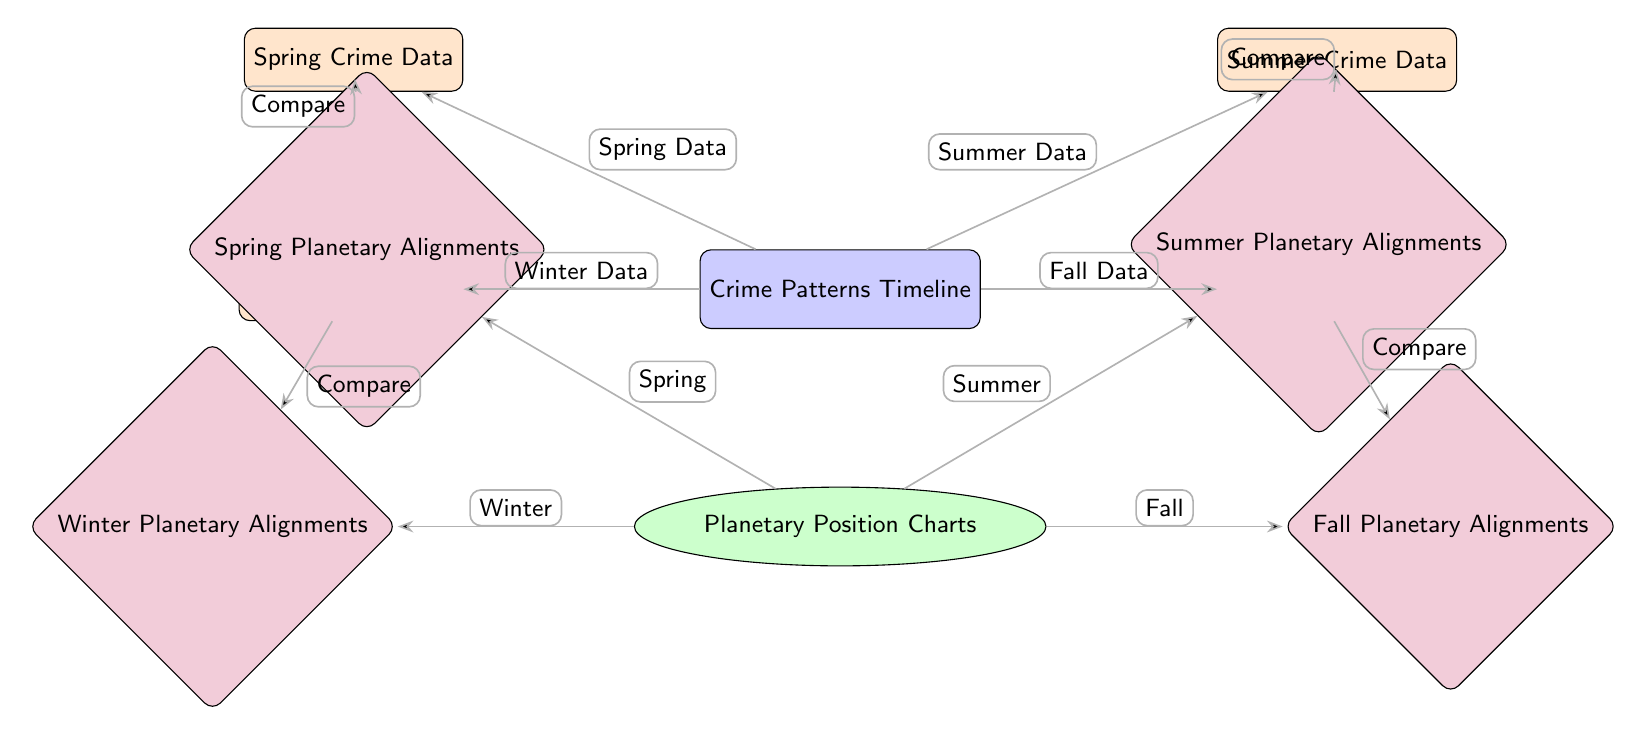What is the title of the diagram? The title is displayed at the top node of the diagram, which explicitly states "Crime Patterns Timeline."
Answer: Crime Patterns Timeline Which season has its crime data represented on the left side of the timeline? The leftmost data node connected to the crime timeline is labeled "Winter Crime Data," indicating that winter is represented here.
Answer: Winter How many seasons are represented in the diagram? By counting the nodes for crime data on the timeline, there are four seasons labeled: Winter, Spring, Summer, and Fall.
Answer: Four What type of node is used to represent the "Summer Planetary Alignments"? The "Summer Planetary Alignments" node is shaped as a diamond, which is a specific style designated for alignment nodes in this diagram.
Answer: Diamond Which crime data node is connected to the fall alignment? The diagram shows that the "Fall Crime Data" node connects directly to the "Fall Planetary Alignments," as indicated on the right side near the fall section.
Answer: Fall Crime Data How does the spring crime data relate to the planetary alignment in the diagram? Following the arrows from the "Spring Crime Data" node, it connects to the "Spring Planetary Alignments" node, indicating a comparison between spring crime data and planetary positions during spring.
Answer: Compare What color is used for the crime data nodes in the diagram? The nodes for crime data are filled with an orange color, clearly distinguishing them from other elements in the diagram.
Answer: Orange Which alignment node is shown at the bottom left of the planetary position charts? The alignment node in the bottom left area connecting to the planetary position charts is the "Winter Planetary Alignments."
Answer: Winter Planetary Alignments What is the relationship between "Winter Crime Data" and "Winter Planetary Alignments"? The diagram illustrates a connection via an edge labeled "Compare," showing that the winter crime data is being compared to the winter planetary alignments.
Answer: Compare 